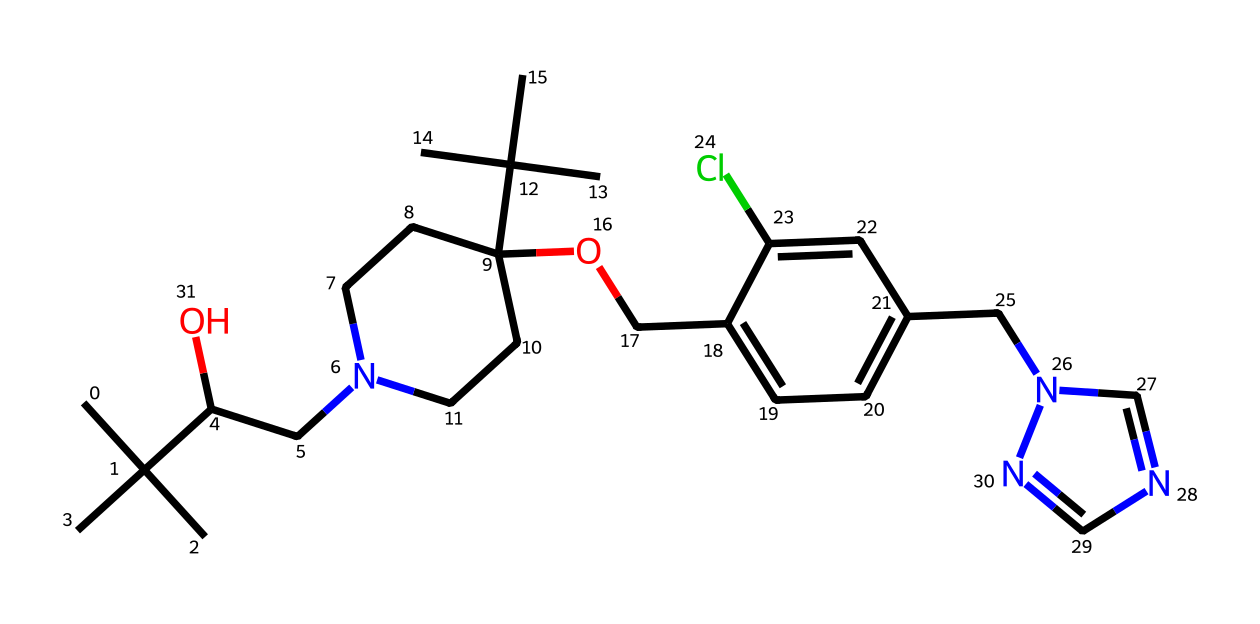What is the total number of carbon atoms in propiconazole? By analyzing the SMILES representation, count every instance of "C" representing carbon. In the provided SMILES, there are 23 carbon atoms.
Answer: 23 How many nitrogen atoms are present in the structure of propiconazole? In the SMILES, the instances of "N" indicate nitrogen. There are 3 occurrences of "N," meaning there are 3 nitrogen atoms in the structure.
Answer: 3 What functional group is indicated by the "O" in the structure? The "O" in the SMILES is part of an ether or alcohol functional group, depending on its position. In this case, it is attached to a carbon chain indicating it is likely an alcohol.
Answer: alcohol What is the significance of the chlorine atom in propiconazole's structure? The chlorine atom is represented by "Cl" in the SMILES and indicates that the chemical possesses halogen substituents, which can affect properties like reactivity and biocidal activity.
Answer: halogen How does the bulky aliphatic side chains impact the solubility of propiconazole? The large aliphatic chains (represented by the carbon clusters) enhance the lipophilicity of propiconazole, which helps it dissolve in organic solvents but may reduce water solubility, affecting its application.
Answer: lipophilicity What role does the nitrogen in the imidazole ring play in propiconazole's fungicidal activity? The nitrogen in the imidazole ring contributes to the chemical's ability to interfere with fungal cell growth and reproduction by being part of the active site in enzymes, impacting its fungicidal mechanisms.
Answer: fungicidal activity In what type of applications is propiconazole commonly used? Propiconazole is widely utilized in agricultural applications and also found in construction sealants and coatings due to its fungicidal properties that prevent mold and mildew growth.
Answer: construction sealants 